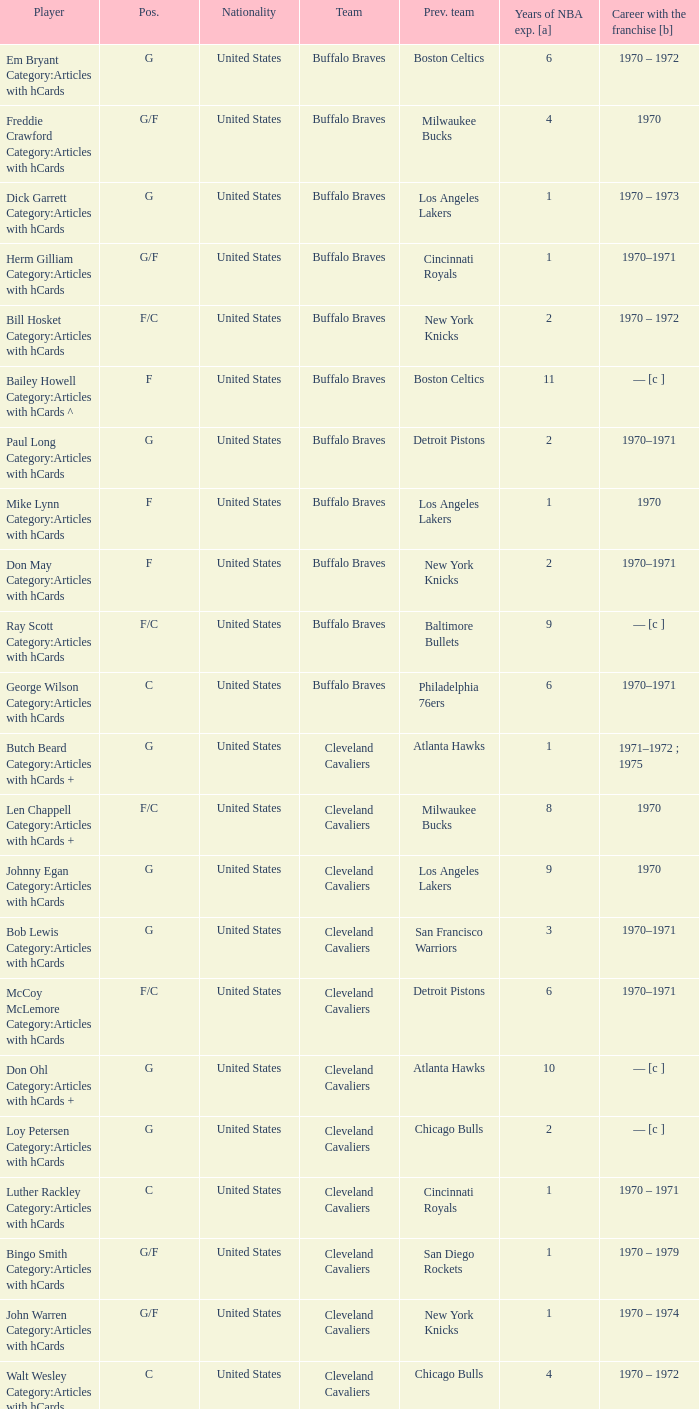How many years of NBA experience does the player who plays position g for the Portland Trail Blazers? 2.0. 